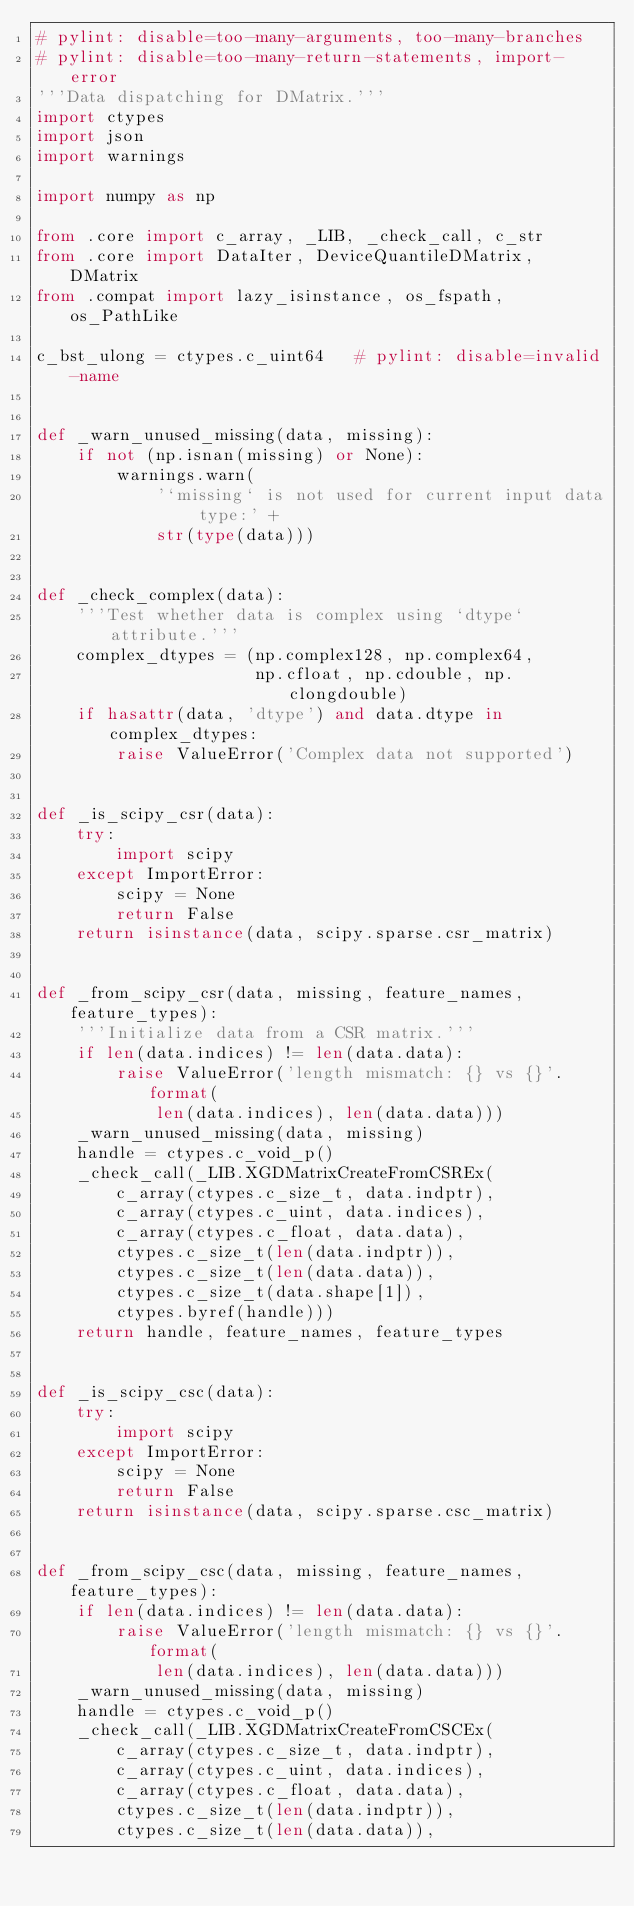<code> <loc_0><loc_0><loc_500><loc_500><_Python_># pylint: disable=too-many-arguments, too-many-branches
# pylint: disable=too-many-return-statements, import-error
'''Data dispatching for DMatrix.'''
import ctypes
import json
import warnings

import numpy as np

from .core import c_array, _LIB, _check_call, c_str
from .core import DataIter, DeviceQuantileDMatrix, DMatrix
from .compat import lazy_isinstance, os_fspath, os_PathLike

c_bst_ulong = ctypes.c_uint64   # pylint: disable=invalid-name


def _warn_unused_missing(data, missing):
    if not (np.isnan(missing) or None):
        warnings.warn(
            '`missing` is not used for current input data type:' +
            str(type(data)))


def _check_complex(data):
    '''Test whether data is complex using `dtype` attribute.'''
    complex_dtypes = (np.complex128, np.complex64,
                      np.cfloat, np.cdouble, np.clongdouble)
    if hasattr(data, 'dtype') and data.dtype in complex_dtypes:
        raise ValueError('Complex data not supported')


def _is_scipy_csr(data):
    try:
        import scipy
    except ImportError:
        scipy = None
        return False
    return isinstance(data, scipy.sparse.csr_matrix)


def _from_scipy_csr(data, missing, feature_names, feature_types):
    '''Initialize data from a CSR matrix.'''
    if len(data.indices) != len(data.data):
        raise ValueError('length mismatch: {} vs {}'.format(
            len(data.indices), len(data.data)))
    _warn_unused_missing(data, missing)
    handle = ctypes.c_void_p()
    _check_call(_LIB.XGDMatrixCreateFromCSREx(
        c_array(ctypes.c_size_t, data.indptr),
        c_array(ctypes.c_uint, data.indices),
        c_array(ctypes.c_float, data.data),
        ctypes.c_size_t(len(data.indptr)),
        ctypes.c_size_t(len(data.data)),
        ctypes.c_size_t(data.shape[1]),
        ctypes.byref(handle)))
    return handle, feature_names, feature_types


def _is_scipy_csc(data):
    try:
        import scipy
    except ImportError:
        scipy = None
        return False
    return isinstance(data, scipy.sparse.csc_matrix)


def _from_scipy_csc(data, missing, feature_names, feature_types):
    if len(data.indices) != len(data.data):
        raise ValueError('length mismatch: {} vs {}'.format(
            len(data.indices), len(data.data)))
    _warn_unused_missing(data, missing)
    handle = ctypes.c_void_p()
    _check_call(_LIB.XGDMatrixCreateFromCSCEx(
        c_array(ctypes.c_size_t, data.indptr),
        c_array(ctypes.c_uint, data.indices),
        c_array(ctypes.c_float, data.data),
        ctypes.c_size_t(len(data.indptr)),
        ctypes.c_size_t(len(data.data)),</code> 